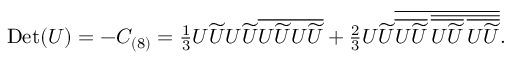Convert formula to latex. <formula><loc_0><loc_0><loc_500><loc_500>\begin{array} { r } { D e t ( U ) = - C _ { ( 8 ) } = \frac { 1 } { 3 } U \widetilde { U } U \widetilde { U } \overline { { U \widetilde { U } U \widetilde { U } } } + \frac { 2 } { 3 } U \widetilde { U } \overline { { \overline { { U \widetilde { U } } } \, \overline { { \overline { { U \widetilde { U } } } \, \overline { { U \widetilde { U } } } } } } } . } \end{array}</formula> 